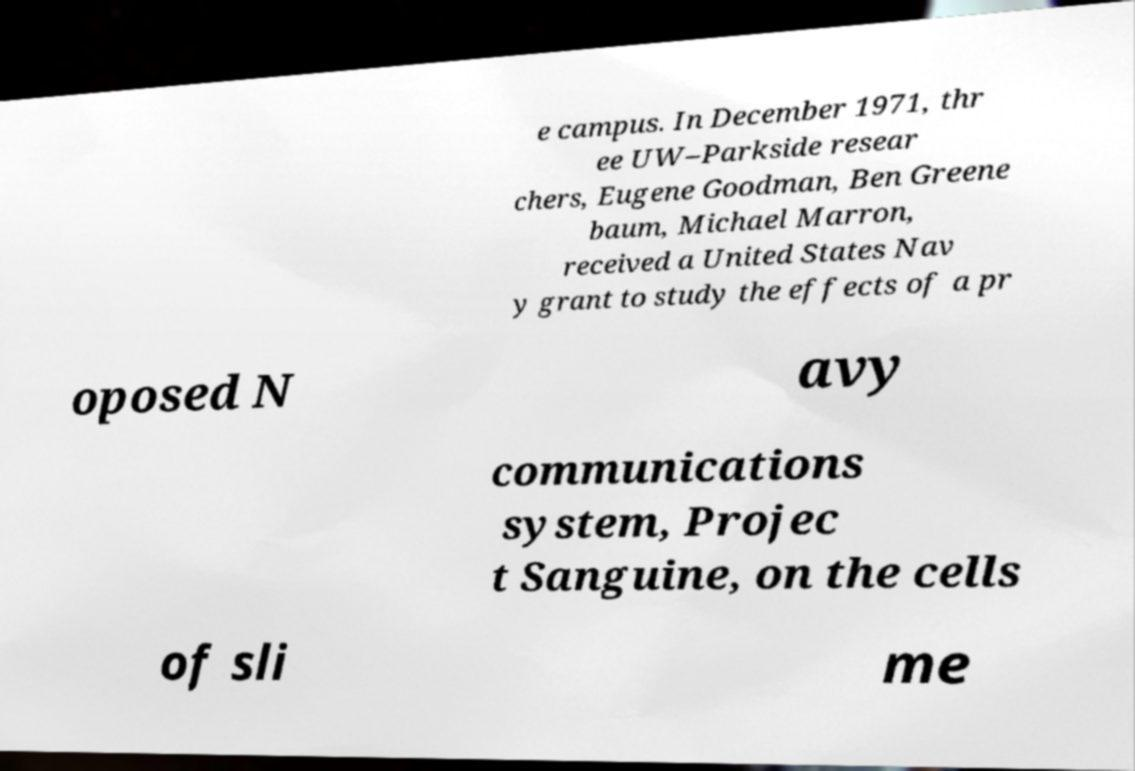What messages or text are displayed in this image? I need them in a readable, typed format. e campus. In December 1971, thr ee UW–Parkside resear chers, Eugene Goodman, Ben Greene baum, Michael Marron, received a United States Nav y grant to study the effects of a pr oposed N avy communications system, Projec t Sanguine, on the cells of sli me 